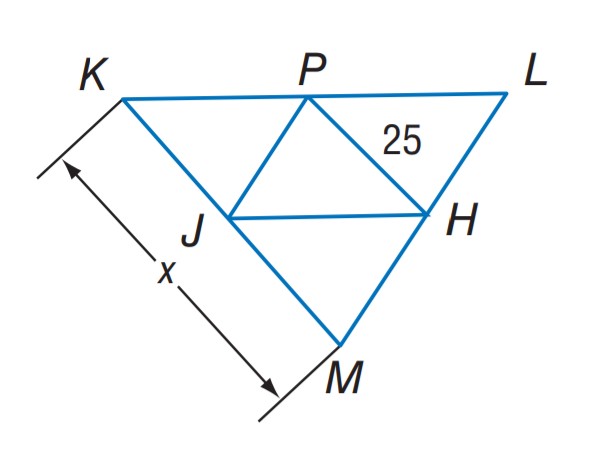Question: J H, J P, and P H are midsegments of \triangle K L M. Find x.
Choices:
A. 12.5
B. 20
C. 25
D. 50
Answer with the letter. Answer: D 